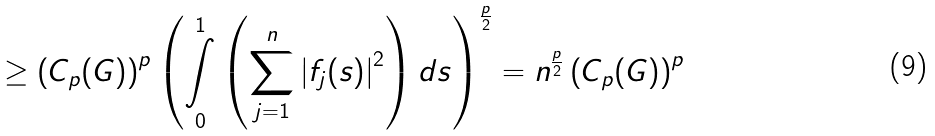Convert formula to latex. <formula><loc_0><loc_0><loc_500><loc_500>\geq \left ( C _ { p } ( G ) \right ) ^ { p } \left ( \underset { 0 } { \overset { 1 } { \int } } \left ( \underset { j = 1 } { \overset { n } { \sum } } \left | f _ { j } ( s ) \right | ^ { 2 } \right ) d s \right ) ^ { \frac { p } { 2 } } = n ^ { \frac { p } { 2 } } \left ( C _ { p } ( G ) \right ) ^ { p }</formula> 